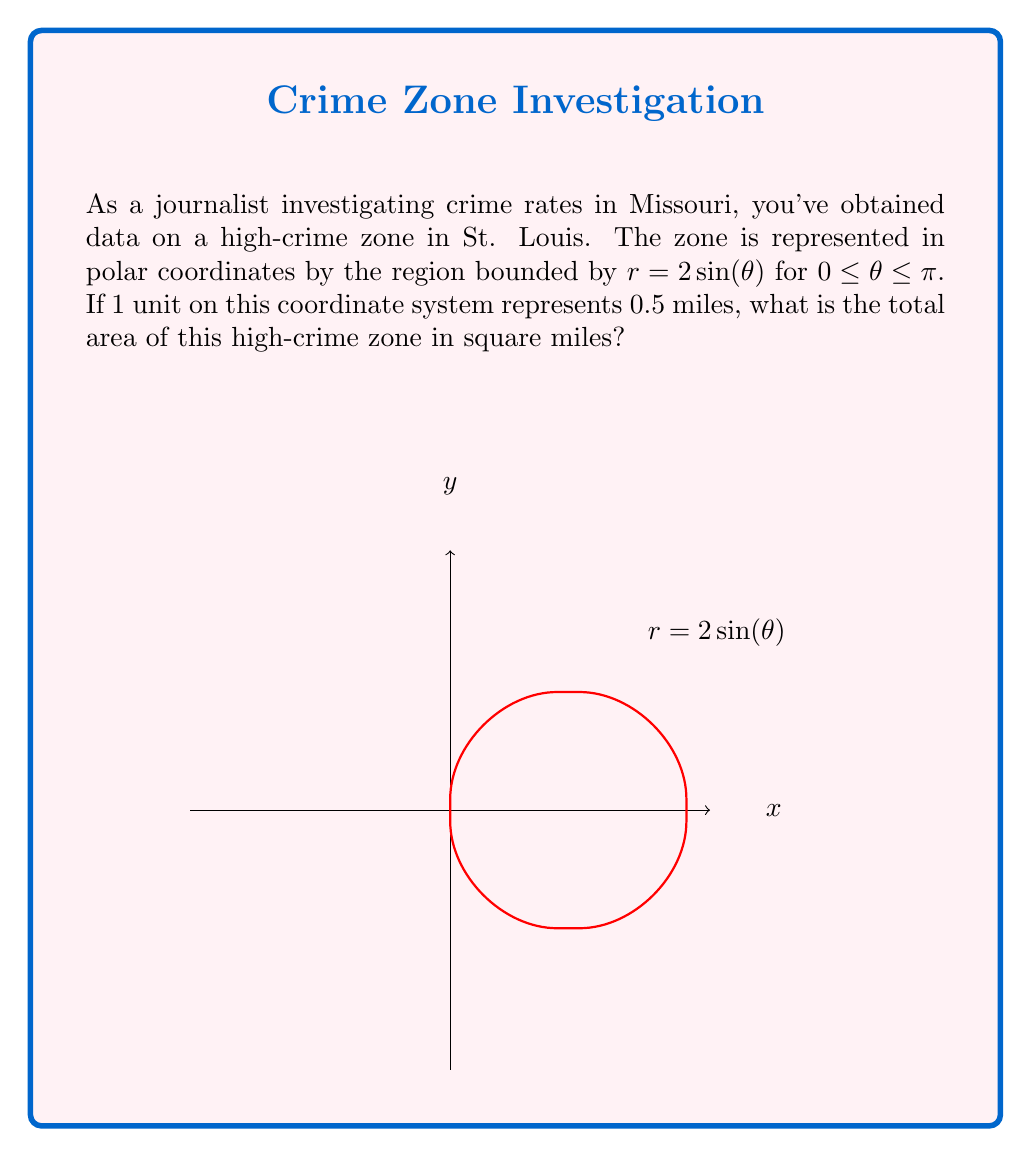What is the answer to this math problem? Let's approach this step-by-step:

1) The area of a region in polar coordinates is given by the formula:

   $$A = \frac{1}{2} \int_a^b r^2(\theta) d\theta$$

2) In this case, $r(\theta) = 2\sin(\theta)$, $a = 0$, and $b = \pi$

3) Substituting into the formula:

   $$A = \frac{1}{2} \int_0^\pi (2\sin(\theta))^2 d\theta$$

4) Simplify the integrand:

   $$A = \frac{1}{2} \int_0^\pi 4\sin^2(\theta) d\theta$$

5) Use the trigonometric identity $\sin^2(\theta) = \frac{1 - \cos(2\theta)}{2}$:

   $$A = \frac{1}{2} \int_0^\pi 4 \cdot \frac{1 - \cos(2\theta)}{2} d\theta = \int_0^\pi (1 - \cos(2\theta)) d\theta$$

6) Integrate:

   $$A = [\theta - \frac{1}{2}\sin(2\theta)]_0^\pi = (\pi - 0) - (\frac{1}{2}\sin(2\pi) - \frac{1}{2}\sin(0)) = \pi$$

7) This result is in square units. Since 1 unit = 0.5 miles, we need to multiply by $(0.5)^2 = 0.25$ to get square miles:

   $$A_{miles} = \pi \cdot 0.25 = \frac{\pi}{4} \approx 0.7854$$

Therefore, the area of the high-crime zone is approximately 0.7854 square miles.
Answer: $\frac{\pi}{4}$ square miles 